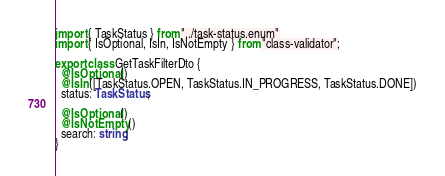<code> <loc_0><loc_0><loc_500><loc_500><_TypeScript_>import { TaskStatus } from "../task-status.enum"
import { IsOptional, IsIn, IsNotEmpty } from "class-validator";

export class GetTaskFilterDto {
  @IsOptional()
  @IsIn([TaskStatus.OPEN, TaskStatus.IN_PROGRESS, TaskStatus.DONE])
  status: TaskStatus;

  @IsOptional()
  @IsNotEmpty()
  search: string;
}
</code> 